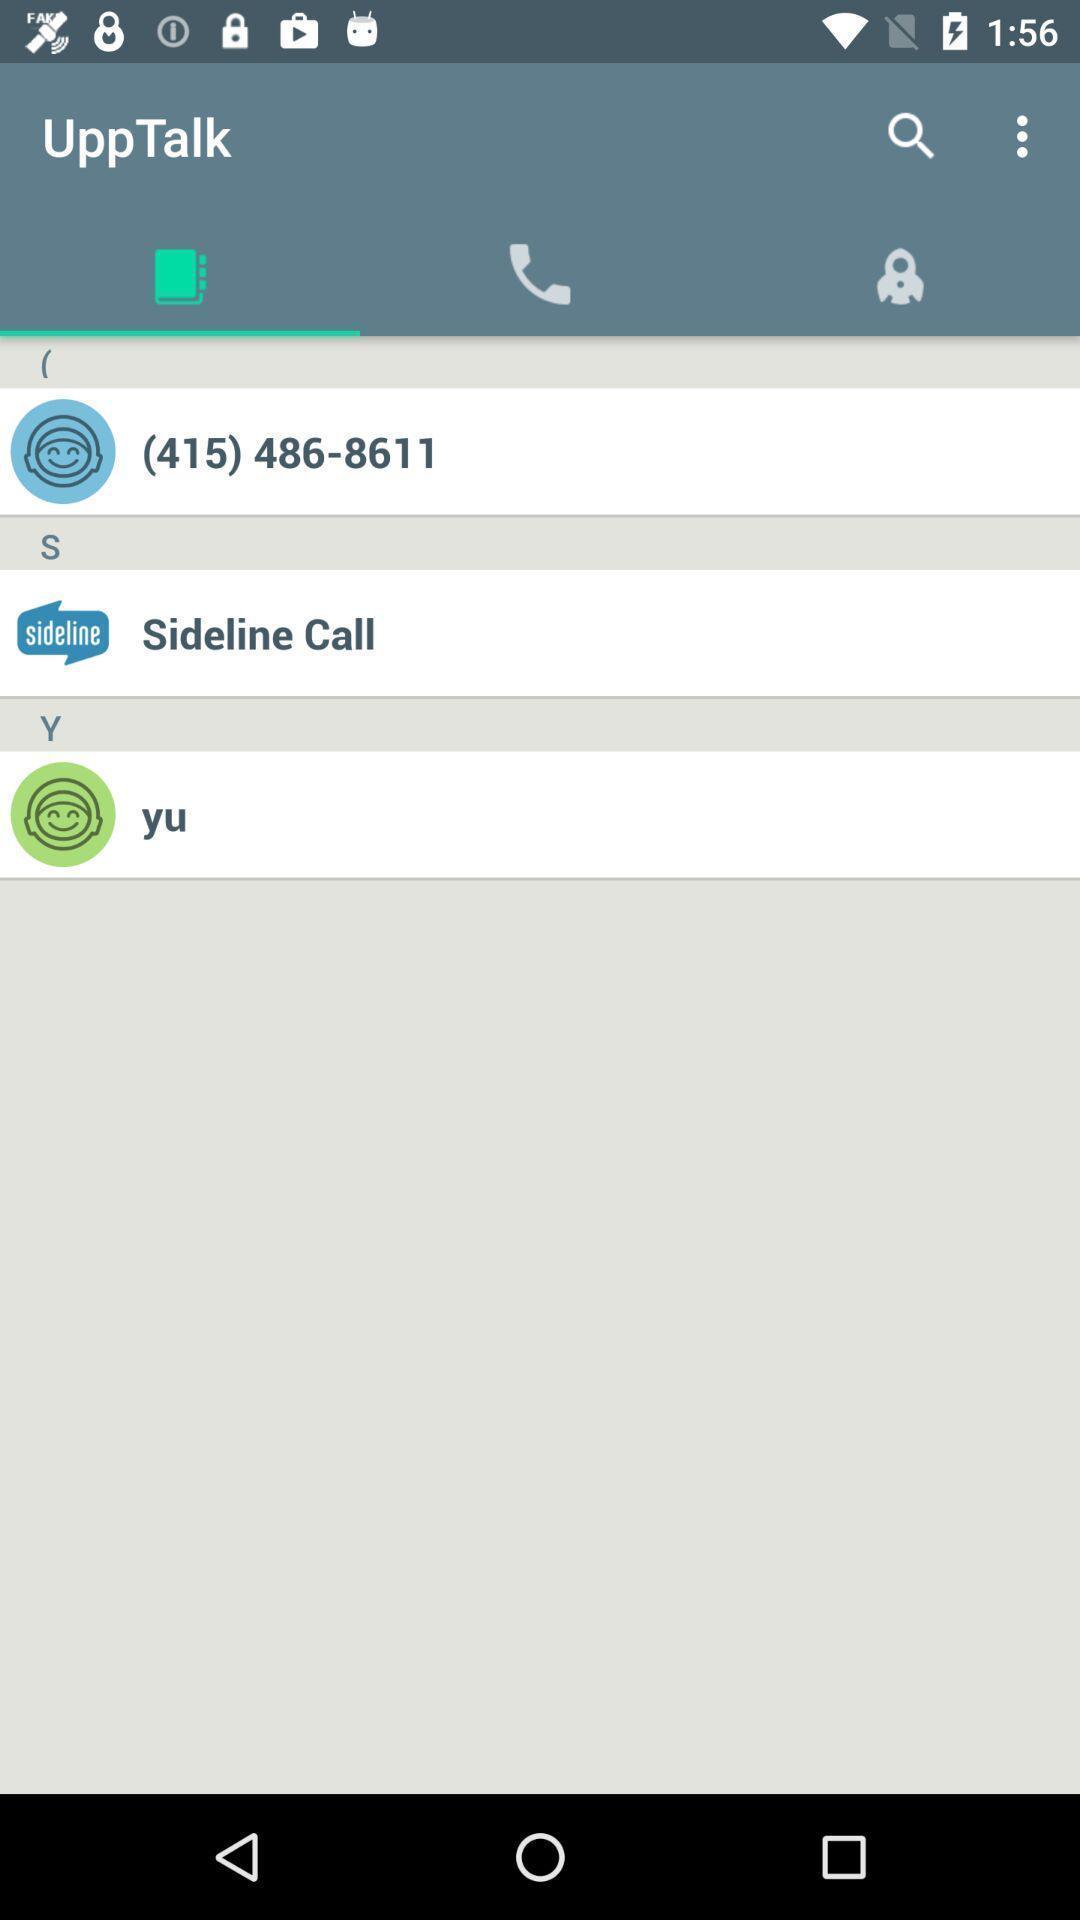Tell me about the visual elements in this screen capture. Page displaying the talking app. 